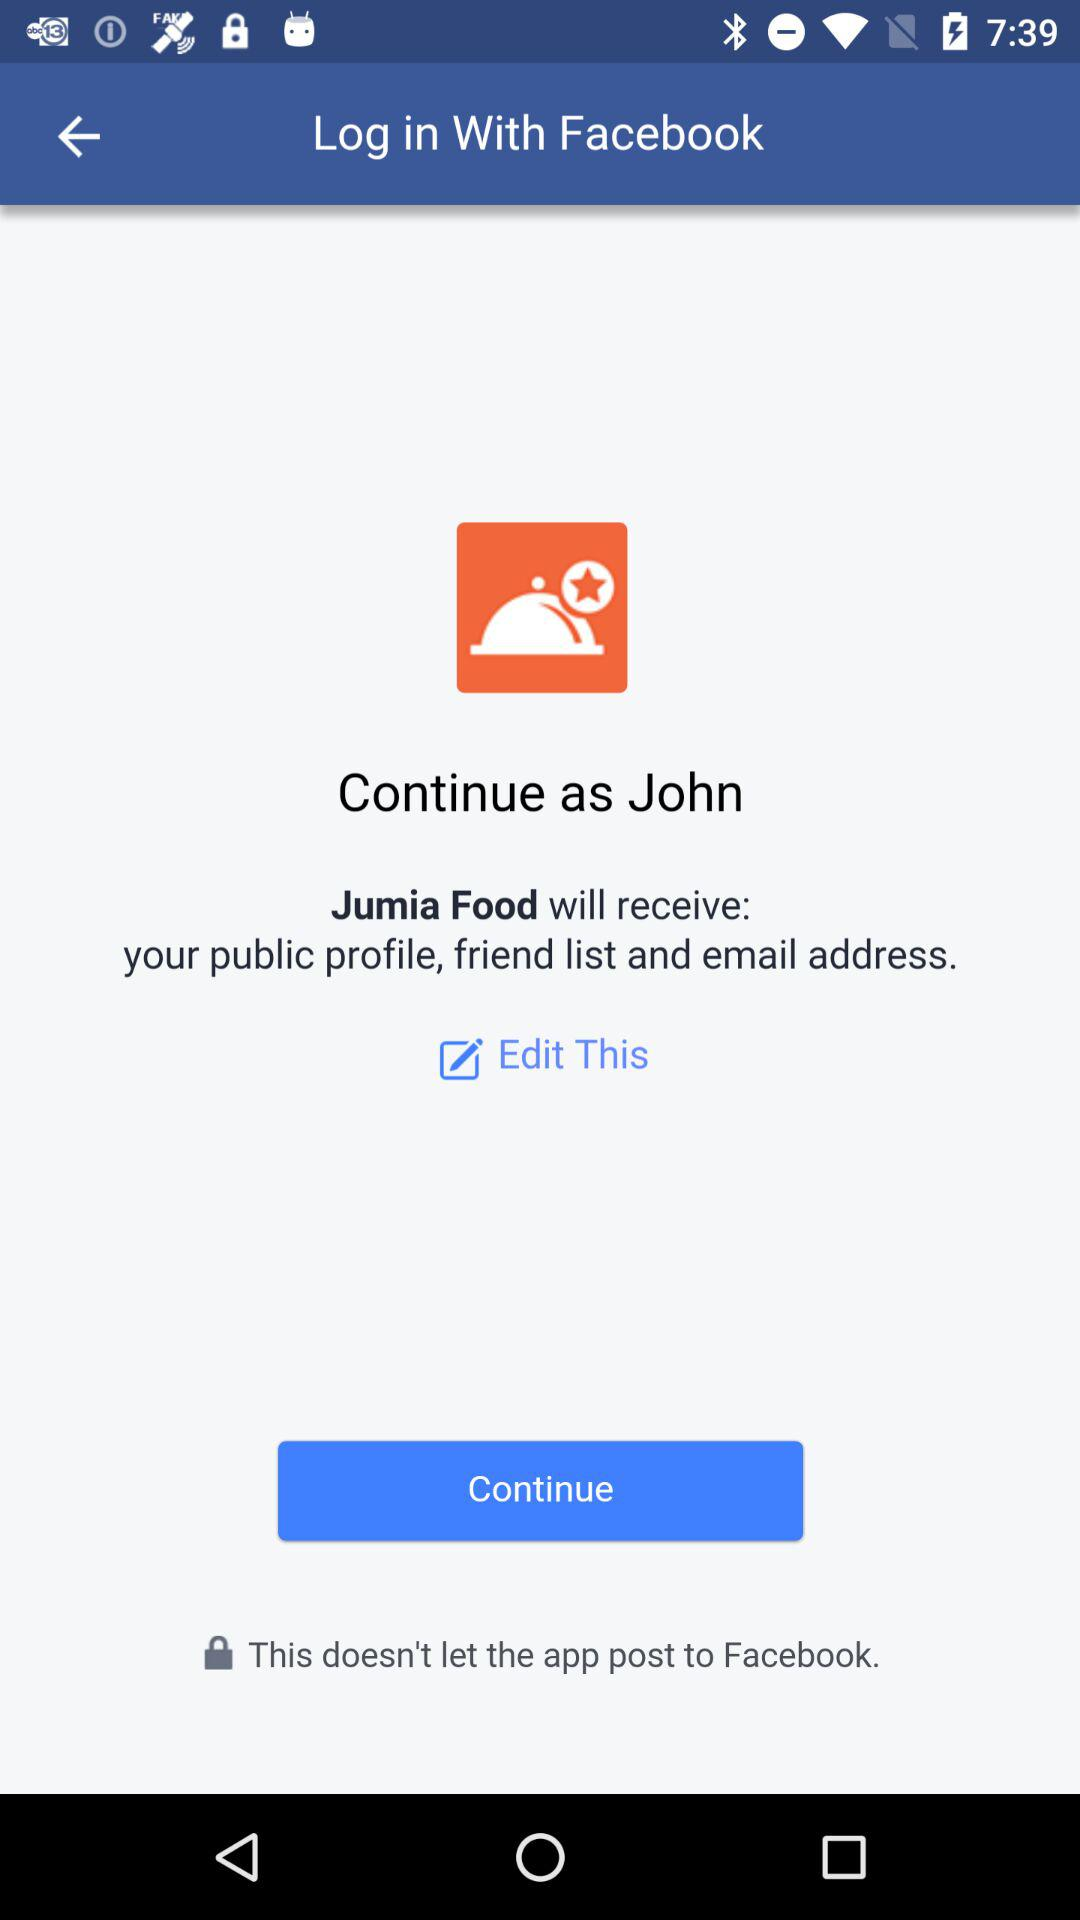What application is asking for permission? The application asking for permission is "Jumia Food". 